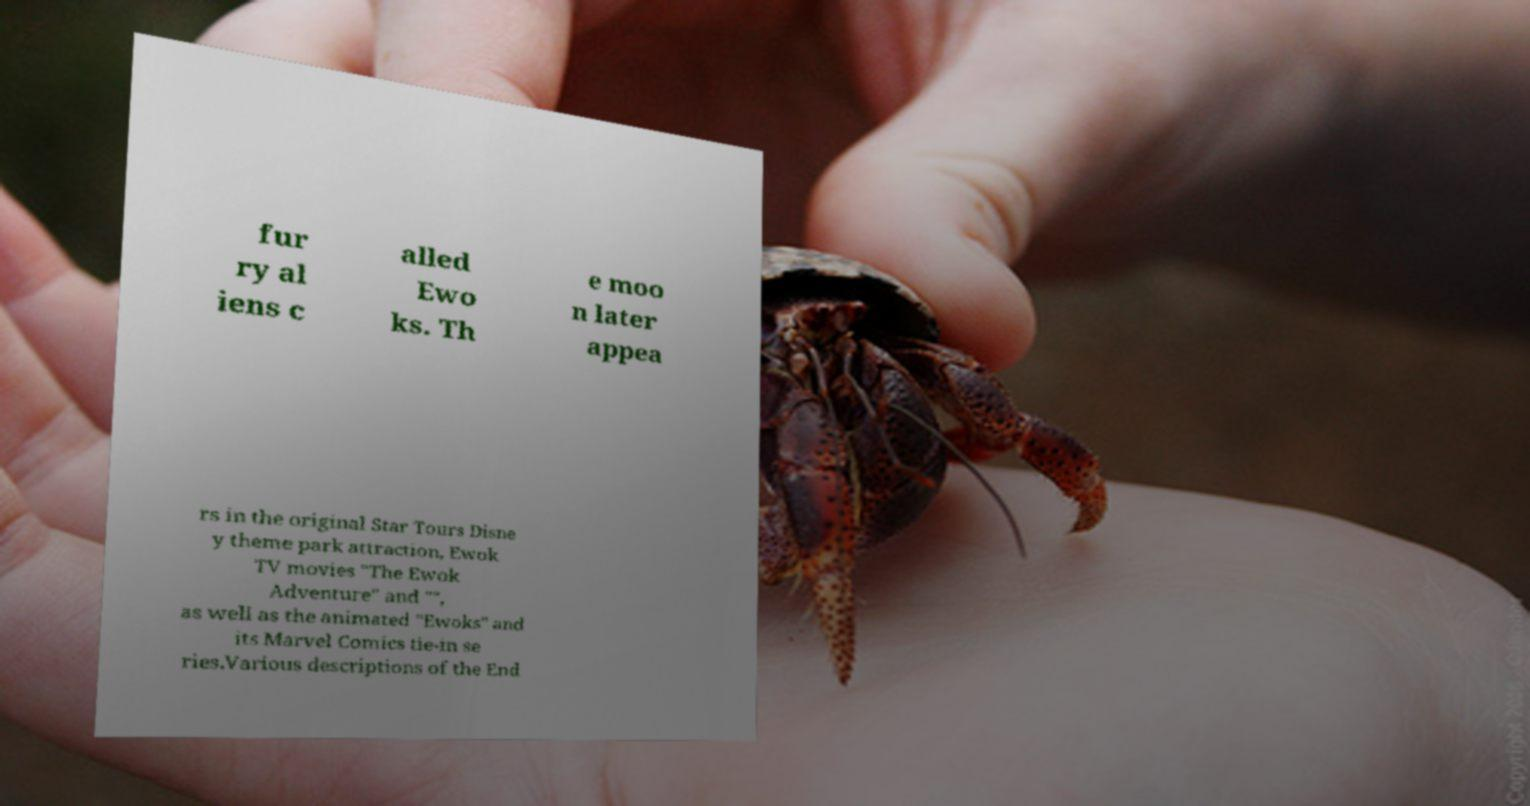Could you extract and type out the text from this image? fur ry al iens c alled Ewo ks. Th e moo n later appea rs in the original Star Tours Disne y theme park attraction, Ewok TV movies "The Ewok Adventure" and "", as well as the animated "Ewoks" and its Marvel Comics tie-in se ries.Various descriptions of the End 